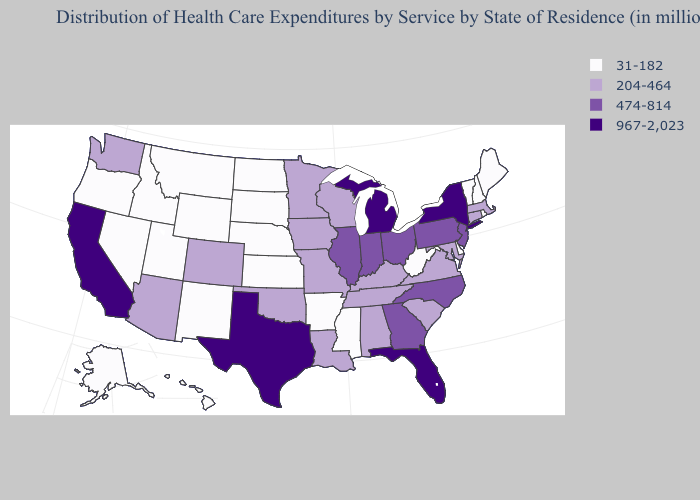Name the states that have a value in the range 31-182?
Quick response, please. Alaska, Arkansas, Delaware, Hawaii, Idaho, Kansas, Maine, Mississippi, Montana, Nebraska, Nevada, New Hampshire, New Mexico, North Dakota, Oregon, Rhode Island, South Dakota, Utah, Vermont, West Virginia, Wyoming. Among the states that border Kentucky , which have the lowest value?
Concise answer only. West Virginia. Name the states that have a value in the range 204-464?
Keep it brief. Alabama, Arizona, Colorado, Connecticut, Iowa, Kentucky, Louisiana, Maryland, Massachusetts, Minnesota, Missouri, Oklahoma, South Carolina, Tennessee, Virginia, Washington, Wisconsin. What is the value of Colorado?
Concise answer only. 204-464. Is the legend a continuous bar?
Write a very short answer. No. Name the states that have a value in the range 204-464?
Short answer required. Alabama, Arizona, Colorado, Connecticut, Iowa, Kentucky, Louisiana, Maryland, Massachusetts, Minnesota, Missouri, Oklahoma, South Carolina, Tennessee, Virginia, Washington, Wisconsin. What is the value of North Dakota?
Concise answer only. 31-182. Among the states that border Wisconsin , which have the lowest value?
Write a very short answer. Iowa, Minnesota. Among the states that border Minnesota , does South Dakota have the lowest value?
Concise answer only. Yes. Name the states that have a value in the range 31-182?
Write a very short answer. Alaska, Arkansas, Delaware, Hawaii, Idaho, Kansas, Maine, Mississippi, Montana, Nebraska, Nevada, New Hampshire, New Mexico, North Dakota, Oregon, Rhode Island, South Dakota, Utah, Vermont, West Virginia, Wyoming. What is the lowest value in the USA?
Be succinct. 31-182. What is the value of Minnesota?
Keep it brief. 204-464. How many symbols are there in the legend?
Concise answer only. 4. Which states have the highest value in the USA?
Write a very short answer. California, Florida, Michigan, New York, Texas. What is the lowest value in the USA?
Short answer required. 31-182. 